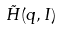<formula> <loc_0><loc_0><loc_500><loc_500>\tilde { H } ( q , I )</formula> 